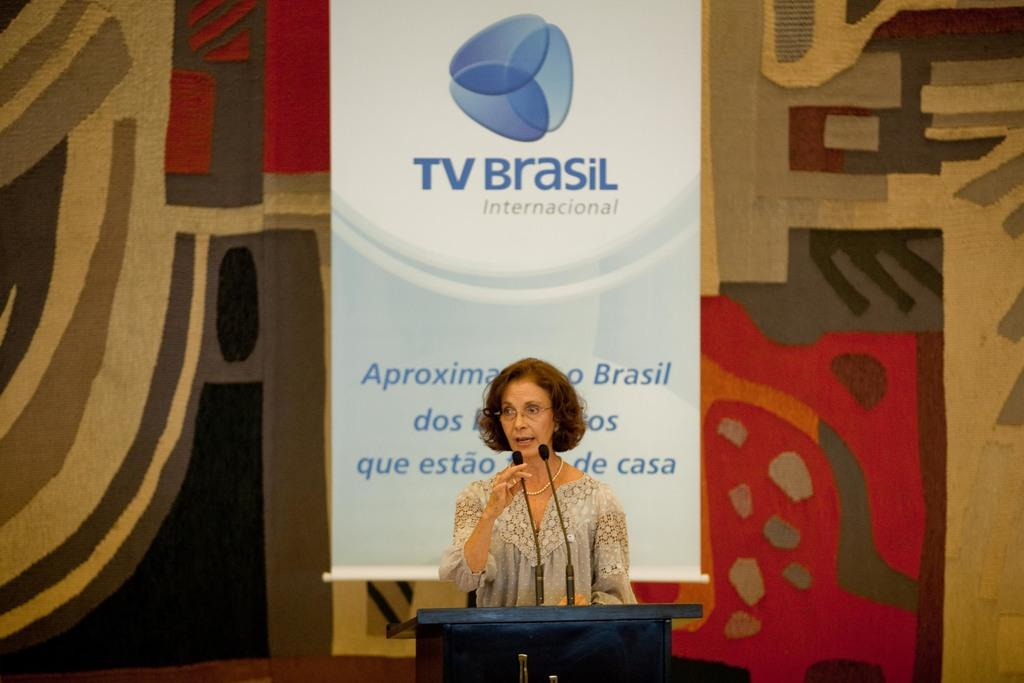<image>
Relay a brief, clear account of the picture shown. A women gives a speech at the TV Brasil international gathering. 